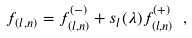Convert formula to latex. <formula><loc_0><loc_0><loc_500><loc_500>f _ { ( l , n ) } = f ^ { ( - ) } _ { ( l , n ) } + s _ { l } ( \lambda ) f ^ { ( + ) } _ { ( l , n ) } \ ,</formula> 